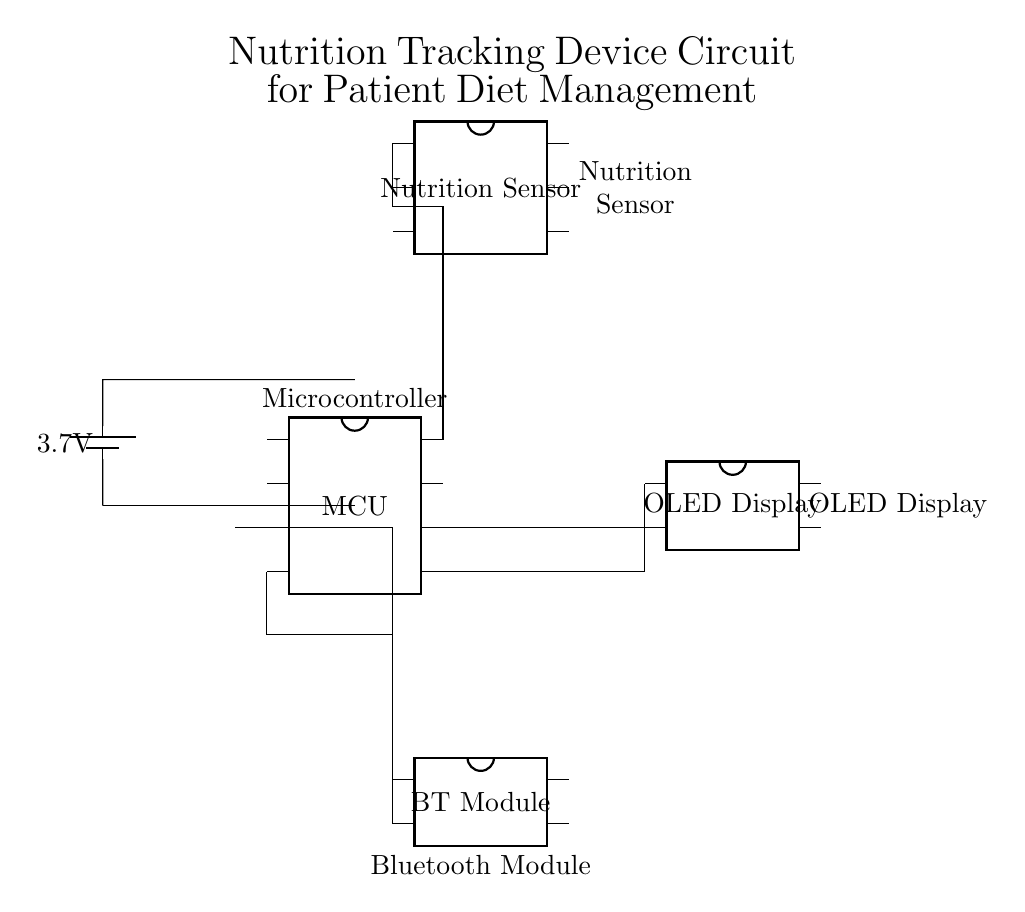What is the power supply voltage? The power supply voltage is shown next to the battery in the circuit diagram, which is labeled as 3.7 volts.
Answer: 3.7V What component processes nutrition data? The nutrition sensor is the component in the circuit that is responsible for collecting nutrition data, as it is connected to the microcontroller.
Answer: Nutrition sensor How many pins does the microcontroller have? The microcontroller is represented in the circuit diagram as a DIP chip with 8 pins, which is typical for a small MCU.
Answer: 8 Which module is used for wireless communication? The Bluetooth module in the circuit is specifically indicated as handling wireless communication, as it connects to the microcontroller for that purpose.
Answer: Bluetooth module What is the connection from the microcontroller to the OLED display? The connections from the microcontroller to the OLED display are made via pins 5 and 6, indicating data transfer for displaying nutritional information.
Answer: Pins 5 and 6 What type of display is used in this device? The circuit specifies an OLED display, which is a common type of display used for its clarity and low power consumption.
Answer: OLED display What role does the microcontroller play in this circuit? The microcontroller serves as the main control unit, processing data from the nutrition sensor and managing communication with the display and Bluetooth module.
Answer: Main control unit 